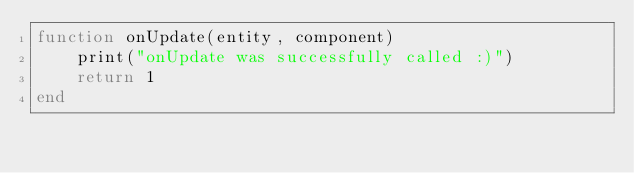<code> <loc_0><loc_0><loc_500><loc_500><_Lua_>function onUpdate(entity, component)
    print("onUpdate was successfully called :)")
    return 1
end</code> 